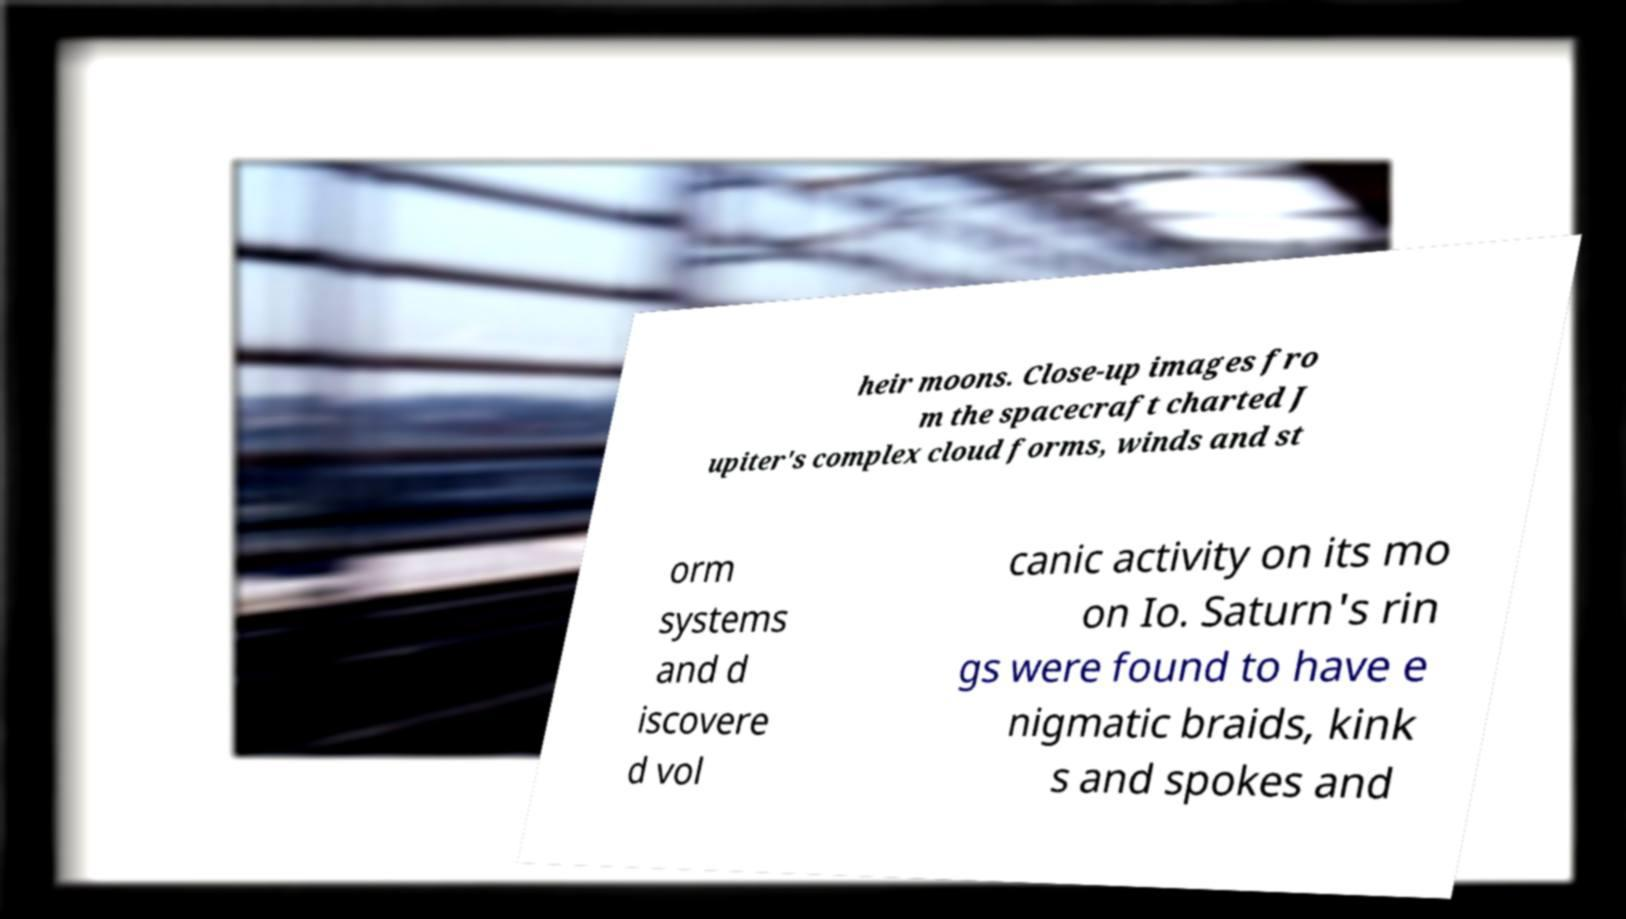Can you read and provide the text displayed in the image?This photo seems to have some interesting text. Can you extract and type it out for me? heir moons. Close-up images fro m the spacecraft charted J upiter's complex cloud forms, winds and st orm systems and d iscovere d vol canic activity on its mo on Io. Saturn's rin gs were found to have e nigmatic braids, kink s and spokes and 